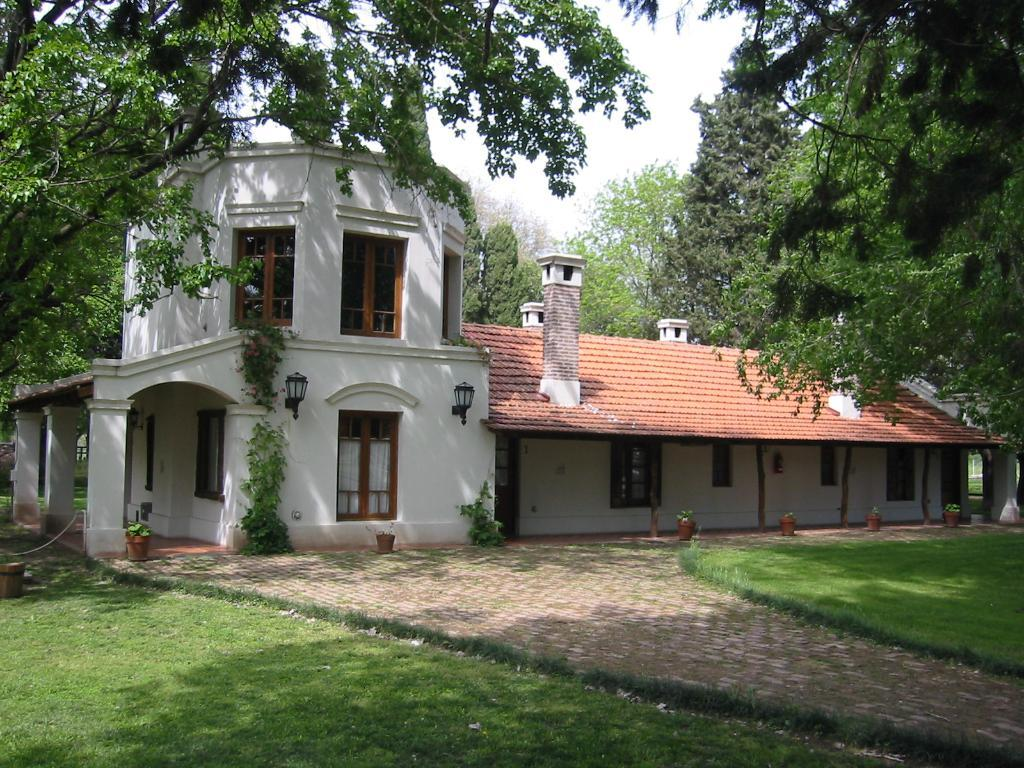What type of structure is in the picture? There is a house in the picture. What is around the house? The house is surrounded by a beautiful garden. What can be found in the garden? There are many trees in the garden. What type of flowers can be seen growing in the lift in the image? There is no lift present in the image, and therefore no flowers growing in it. 